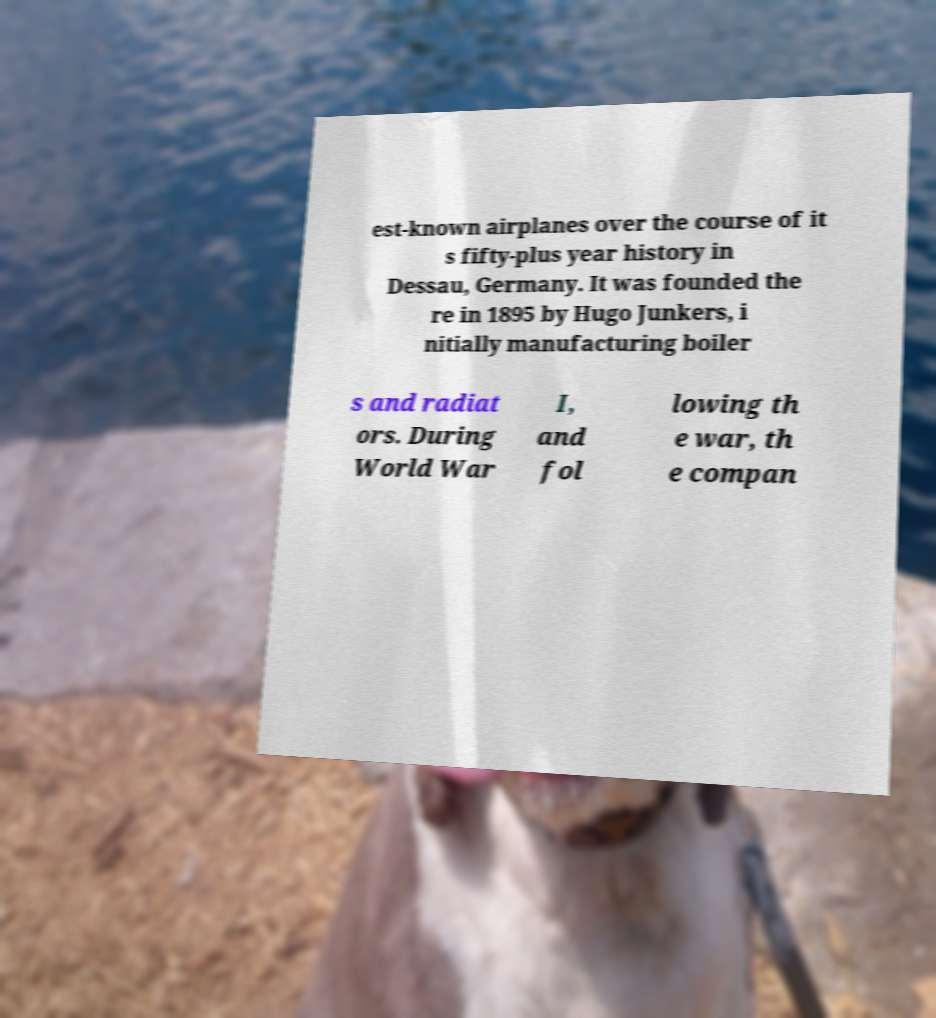For documentation purposes, I need the text within this image transcribed. Could you provide that? est-known airplanes over the course of it s fifty-plus year history in Dessau, Germany. It was founded the re in 1895 by Hugo Junkers, i nitially manufacturing boiler s and radiat ors. During World War I, and fol lowing th e war, th e compan 